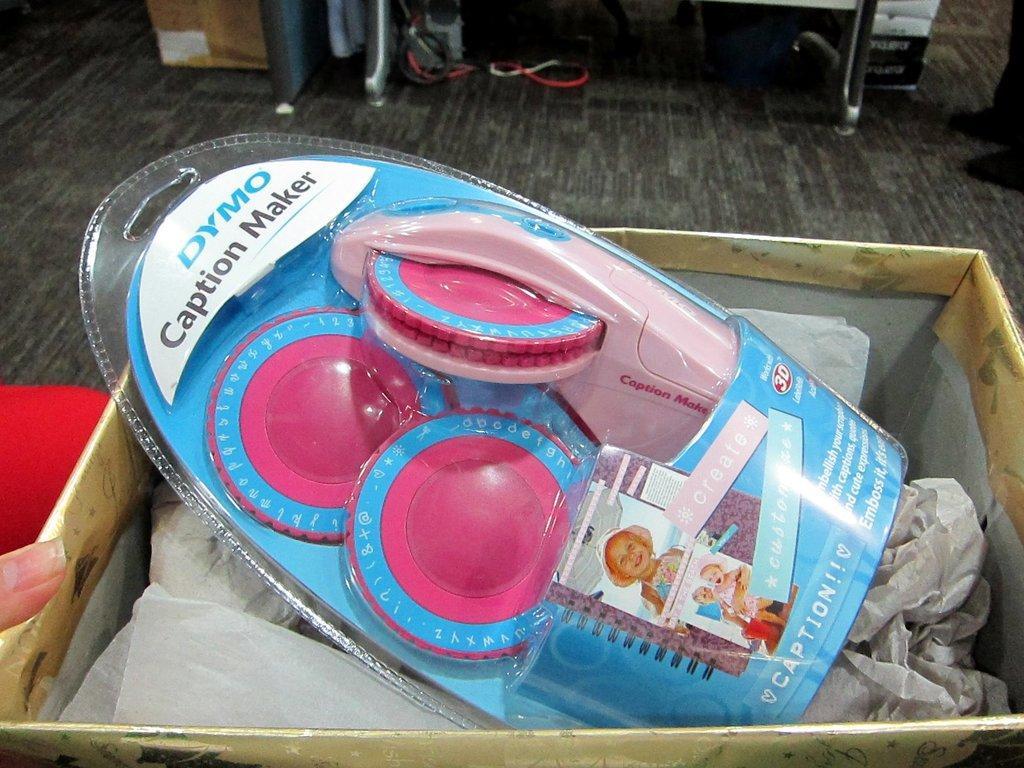Could you give a brief overview of what you see in this image? In this image I see a thing over here which is of blue and pink in color and I see something is written over here and I see pictures of children and this thing is in the box and I see few white papers and I see a person's finger over here and I see the floor and I see another person's legs over here and I see few things over here. 